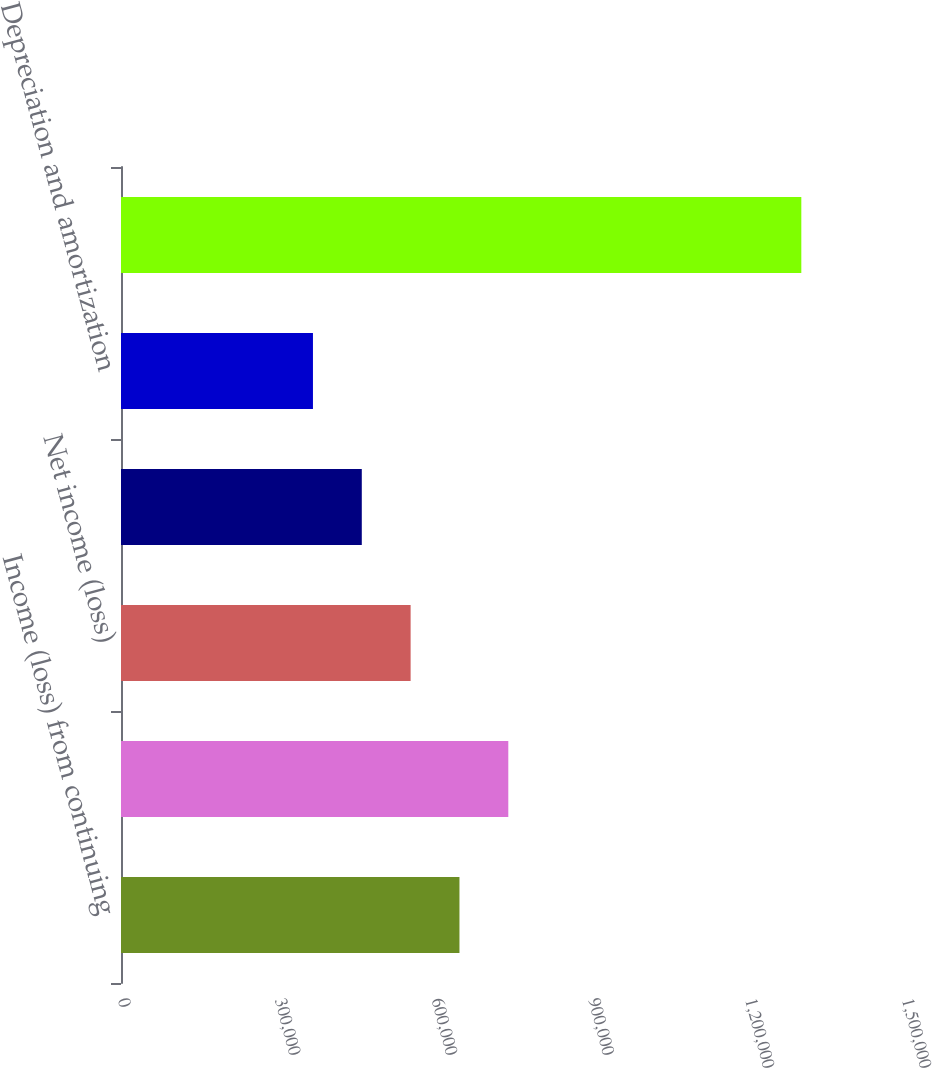<chart> <loc_0><loc_0><loc_500><loc_500><bar_chart><fcel>Income (loss) from continuing<fcel>Income (loss) before<fcel>Net income (loss)<fcel>Interest and debt expense (1)<fcel>Depreciation and amortization<fcel>EBITDA<nl><fcel>647570<fcel>741007<fcel>554134<fcel>460697<fcel>367260<fcel>1.30163e+06<nl></chart> 